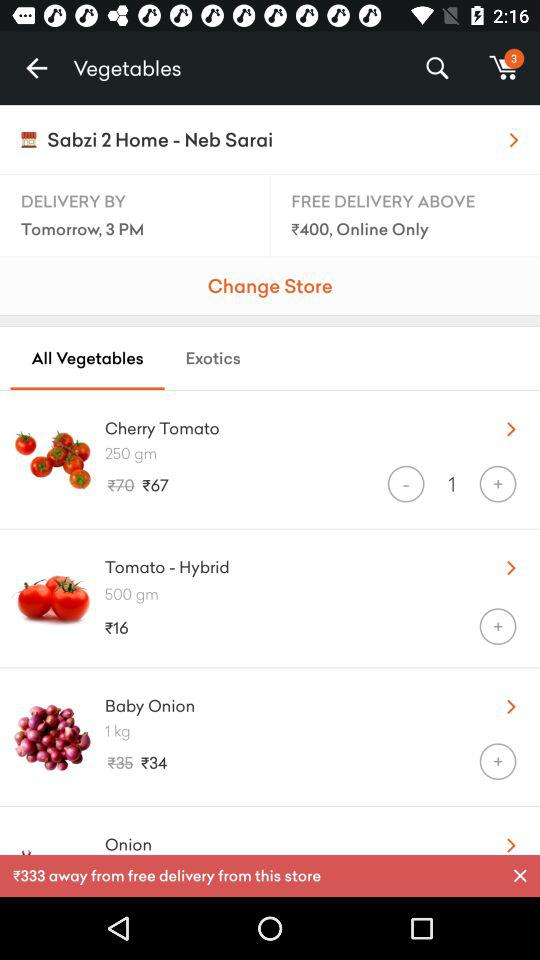When will the item be delivered? The item will be delivered tomorrow by 3 p.m. 